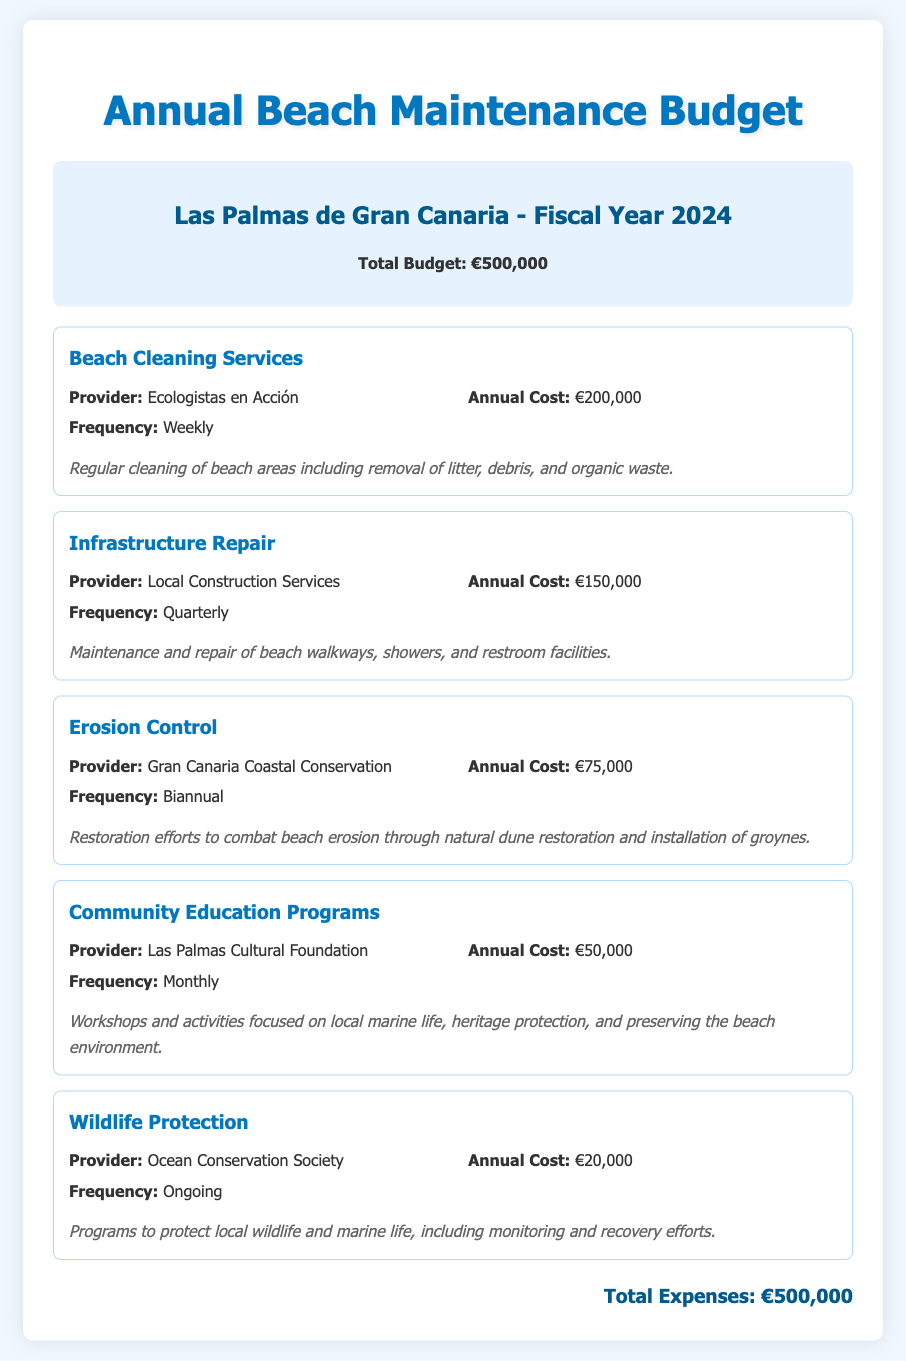What is the total budget? The total budget is clearly stated in the document as €500,000.
Answer: €500,000 Who provides beach cleaning services? The document specifies that Ecologistas en Acción is the provider for beach cleaning services.
Answer: Ecologistas en Acción How often is beach cleaning conducted? The document mentions that beach cleaning services are conducted weekly.
Answer: Weekly What is the annual cost of infrastructure repair? The document states that the annual cost for infrastructure repair is €150,000.
Answer: €150,000 What percentage of the total budget is allocated to community education programs? The cost for community education programs is €50,000, which is 10% of the total budget of €500,000.
Answer: 10% Which organization is responsible for erosion control? The document indicates that Gran Canaria Coastal Conservation handles erosion control.
Answer: Gran Canaria Coastal Conservation What type of programs does the Ocean Conservation Society provide? The document describes programs focused on wildlife protection as being provided by the Ocean Conservation Society.
Answer: Wildlife protection How frequently are erosion control efforts carried out? The frequency of erosion control efforts is specified as biannual.
Answer: Biannual What is the total cost allocated to wildlife protection? The document states that the annual cost for wildlife protection is €20,000.
Answer: €20,000 